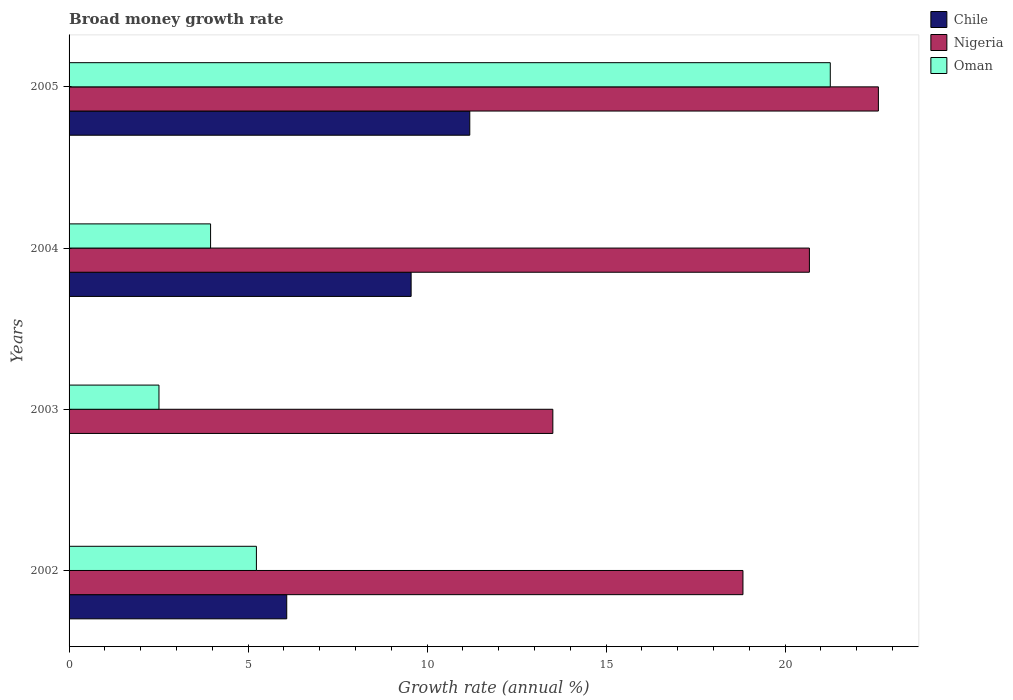How many bars are there on the 3rd tick from the top?
Make the answer very short. 2. How many bars are there on the 4th tick from the bottom?
Your response must be concise. 3. What is the label of the 2nd group of bars from the top?
Offer a very short reply. 2004. What is the growth rate in Nigeria in 2004?
Give a very brief answer. 20.68. Across all years, what is the maximum growth rate in Chile?
Keep it short and to the point. 11.19. Across all years, what is the minimum growth rate in Nigeria?
Give a very brief answer. 13.51. What is the total growth rate in Nigeria in the graph?
Ensure brevity in your answer.  75.61. What is the difference between the growth rate in Chile in 2002 and that in 2004?
Offer a terse response. -3.47. What is the difference between the growth rate in Chile in 2005 and the growth rate in Nigeria in 2003?
Offer a terse response. -2.32. What is the average growth rate in Nigeria per year?
Keep it short and to the point. 18.9. In the year 2005, what is the difference between the growth rate in Oman and growth rate in Nigeria?
Your answer should be compact. -1.34. What is the ratio of the growth rate in Nigeria in 2002 to that in 2004?
Provide a succinct answer. 0.91. Is the growth rate in Chile in 2004 less than that in 2005?
Provide a short and direct response. Yes. Is the difference between the growth rate in Oman in 2004 and 2005 greater than the difference between the growth rate in Nigeria in 2004 and 2005?
Your answer should be very brief. No. What is the difference between the highest and the second highest growth rate in Nigeria?
Your answer should be compact. 1.93. What is the difference between the highest and the lowest growth rate in Nigeria?
Keep it short and to the point. 9.09. How many bars are there?
Give a very brief answer. 11. Are all the bars in the graph horizontal?
Offer a terse response. Yes. Does the graph contain any zero values?
Ensure brevity in your answer.  Yes. Does the graph contain grids?
Provide a short and direct response. No. Where does the legend appear in the graph?
Keep it short and to the point. Top right. How many legend labels are there?
Your answer should be compact. 3. What is the title of the graph?
Ensure brevity in your answer.  Broad money growth rate. What is the label or title of the X-axis?
Give a very brief answer. Growth rate (annual %). What is the label or title of the Y-axis?
Keep it short and to the point. Years. What is the Growth rate (annual %) of Chile in 2002?
Ensure brevity in your answer.  6.08. What is the Growth rate (annual %) of Nigeria in 2002?
Your answer should be very brief. 18.82. What is the Growth rate (annual %) of Oman in 2002?
Make the answer very short. 5.23. What is the Growth rate (annual %) in Chile in 2003?
Your response must be concise. 0. What is the Growth rate (annual %) in Nigeria in 2003?
Provide a succinct answer. 13.51. What is the Growth rate (annual %) of Oman in 2003?
Provide a short and direct response. 2.51. What is the Growth rate (annual %) in Chile in 2004?
Your response must be concise. 9.55. What is the Growth rate (annual %) of Nigeria in 2004?
Your answer should be compact. 20.68. What is the Growth rate (annual %) in Oman in 2004?
Make the answer very short. 3.95. What is the Growth rate (annual %) of Chile in 2005?
Make the answer very short. 11.19. What is the Growth rate (annual %) in Nigeria in 2005?
Provide a succinct answer. 22.6. What is the Growth rate (annual %) of Oman in 2005?
Your answer should be compact. 21.26. Across all years, what is the maximum Growth rate (annual %) in Chile?
Offer a terse response. 11.19. Across all years, what is the maximum Growth rate (annual %) in Nigeria?
Provide a short and direct response. 22.6. Across all years, what is the maximum Growth rate (annual %) in Oman?
Give a very brief answer. 21.26. Across all years, what is the minimum Growth rate (annual %) of Chile?
Your response must be concise. 0. Across all years, what is the minimum Growth rate (annual %) in Nigeria?
Make the answer very short. 13.51. Across all years, what is the minimum Growth rate (annual %) of Oman?
Your answer should be very brief. 2.51. What is the total Growth rate (annual %) of Chile in the graph?
Your response must be concise. 26.82. What is the total Growth rate (annual %) of Nigeria in the graph?
Your answer should be very brief. 75.61. What is the total Growth rate (annual %) in Oman in the graph?
Ensure brevity in your answer.  32.96. What is the difference between the Growth rate (annual %) of Nigeria in 2002 and that in 2003?
Offer a terse response. 5.31. What is the difference between the Growth rate (annual %) in Oman in 2002 and that in 2003?
Offer a very short reply. 2.72. What is the difference between the Growth rate (annual %) of Chile in 2002 and that in 2004?
Provide a succinct answer. -3.47. What is the difference between the Growth rate (annual %) in Nigeria in 2002 and that in 2004?
Your answer should be very brief. -1.86. What is the difference between the Growth rate (annual %) in Oman in 2002 and that in 2004?
Keep it short and to the point. 1.28. What is the difference between the Growth rate (annual %) of Chile in 2002 and that in 2005?
Provide a succinct answer. -5.11. What is the difference between the Growth rate (annual %) in Nigeria in 2002 and that in 2005?
Give a very brief answer. -3.78. What is the difference between the Growth rate (annual %) in Oman in 2002 and that in 2005?
Provide a short and direct response. -16.03. What is the difference between the Growth rate (annual %) in Nigeria in 2003 and that in 2004?
Give a very brief answer. -7.17. What is the difference between the Growth rate (annual %) of Oman in 2003 and that in 2004?
Your response must be concise. -1.44. What is the difference between the Growth rate (annual %) of Nigeria in 2003 and that in 2005?
Your answer should be compact. -9.09. What is the difference between the Growth rate (annual %) in Oman in 2003 and that in 2005?
Provide a succinct answer. -18.75. What is the difference between the Growth rate (annual %) in Chile in 2004 and that in 2005?
Offer a terse response. -1.64. What is the difference between the Growth rate (annual %) in Nigeria in 2004 and that in 2005?
Provide a succinct answer. -1.93. What is the difference between the Growth rate (annual %) in Oman in 2004 and that in 2005?
Ensure brevity in your answer.  -17.31. What is the difference between the Growth rate (annual %) in Chile in 2002 and the Growth rate (annual %) in Nigeria in 2003?
Make the answer very short. -7.43. What is the difference between the Growth rate (annual %) of Chile in 2002 and the Growth rate (annual %) of Oman in 2003?
Offer a terse response. 3.57. What is the difference between the Growth rate (annual %) in Nigeria in 2002 and the Growth rate (annual %) in Oman in 2003?
Keep it short and to the point. 16.31. What is the difference between the Growth rate (annual %) of Chile in 2002 and the Growth rate (annual %) of Nigeria in 2004?
Make the answer very short. -14.6. What is the difference between the Growth rate (annual %) in Chile in 2002 and the Growth rate (annual %) in Oman in 2004?
Offer a terse response. 2.13. What is the difference between the Growth rate (annual %) in Nigeria in 2002 and the Growth rate (annual %) in Oman in 2004?
Provide a short and direct response. 14.87. What is the difference between the Growth rate (annual %) in Chile in 2002 and the Growth rate (annual %) in Nigeria in 2005?
Give a very brief answer. -16.52. What is the difference between the Growth rate (annual %) of Chile in 2002 and the Growth rate (annual %) of Oman in 2005?
Your answer should be very brief. -15.18. What is the difference between the Growth rate (annual %) of Nigeria in 2002 and the Growth rate (annual %) of Oman in 2005?
Offer a very short reply. -2.44. What is the difference between the Growth rate (annual %) in Nigeria in 2003 and the Growth rate (annual %) in Oman in 2004?
Provide a short and direct response. 9.56. What is the difference between the Growth rate (annual %) of Nigeria in 2003 and the Growth rate (annual %) of Oman in 2005?
Ensure brevity in your answer.  -7.75. What is the difference between the Growth rate (annual %) in Chile in 2004 and the Growth rate (annual %) in Nigeria in 2005?
Your response must be concise. -13.05. What is the difference between the Growth rate (annual %) in Chile in 2004 and the Growth rate (annual %) in Oman in 2005?
Your response must be concise. -11.71. What is the difference between the Growth rate (annual %) of Nigeria in 2004 and the Growth rate (annual %) of Oman in 2005?
Make the answer very short. -0.58. What is the average Growth rate (annual %) of Chile per year?
Make the answer very short. 6.71. What is the average Growth rate (annual %) in Nigeria per year?
Make the answer very short. 18.9. What is the average Growth rate (annual %) in Oman per year?
Offer a very short reply. 8.24. In the year 2002, what is the difference between the Growth rate (annual %) in Chile and Growth rate (annual %) in Nigeria?
Ensure brevity in your answer.  -12.74. In the year 2002, what is the difference between the Growth rate (annual %) of Chile and Growth rate (annual %) of Oman?
Provide a succinct answer. 0.85. In the year 2002, what is the difference between the Growth rate (annual %) of Nigeria and Growth rate (annual %) of Oman?
Your answer should be compact. 13.59. In the year 2003, what is the difference between the Growth rate (annual %) of Nigeria and Growth rate (annual %) of Oman?
Give a very brief answer. 11. In the year 2004, what is the difference between the Growth rate (annual %) of Chile and Growth rate (annual %) of Nigeria?
Provide a succinct answer. -11.12. In the year 2004, what is the difference between the Growth rate (annual %) of Chile and Growth rate (annual %) of Oman?
Ensure brevity in your answer.  5.6. In the year 2004, what is the difference between the Growth rate (annual %) in Nigeria and Growth rate (annual %) in Oman?
Provide a short and direct response. 16.72. In the year 2005, what is the difference between the Growth rate (annual %) of Chile and Growth rate (annual %) of Nigeria?
Keep it short and to the point. -11.41. In the year 2005, what is the difference between the Growth rate (annual %) of Chile and Growth rate (annual %) of Oman?
Your answer should be very brief. -10.07. In the year 2005, what is the difference between the Growth rate (annual %) in Nigeria and Growth rate (annual %) in Oman?
Make the answer very short. 1.34. What is the ratio of the Growth rate (annual %) of Nigeria in 2002 to that in 2003?
Your answer should be compact. 1.39. What is the ratio of the Growth rate (annual %) in Oman in 2002 to that in 2003?
Make the answer very short. 2.08. What is the ratio of the Growth rate (annual %) of Chile in 2002 to that in 2004?
Your response must be concise. 0.64. What is the ratio of the Growth rate (annual %) of Nigeria in 2002 to that in 2004?
Keep it short and to the point. 0.91. What is the ratio of the Growth rate (annual %) in Oman in 2002 to that in 2004?
Your response must be concise. 1.32. What is the ratio of the Growth rate (annual %) of Chile in 2002 to that in 2005?
Make the answer very short. 0.54. What is the ratio of the Growth rate (annual %) in Nigeria in 2002 to that in 2005?
Provide a succinct answer. 0.83. What is the ratio of the Growth rate (annual %) in Oman in 2002 to that in 2005?
Offer a very short reply. 0.25. What is the ratio of the Growth rate (annual %) in Nigeria in 2003 to that in 2004?
Your answer should be very brief. 0.65. What is the ratio of the Growth rate (annual %) in Oman in 2003 to that in 2004?
Give a very brief answer. 0.64. What is the ratio of the Growth rate (annual %) in Nigeria in 2003 to that in 2005?
Offer a very short reply. 0.6. What is the ratio of the Growth rate (annual %) of Oman in 2003 to that in 2005?
Offer a terse response. 0.12. What is the ratio of the Growth rate (annual %) of Chile in 2004 to that in 2005?
Provide a succinct answer. 0.85. What is the ratio of the Growth rate (annual %) in Nigeria in 2004 to that in 2005?
Keep it short and to the point. 0.91. What is the ratio of the Growth rate (annual %) of Oman in 2004 to that in 2005?
Make the answer very short. 0.19. What is the difference between the highest and the second highest Growth rate (annual %) of Chile?
Your answer should be compact. 1.64. What is the difference between the highest and the second highest Growth rate (annual %) in Nigeria?
Provide a short and direct response. 1.93. What is the difference between the highest and the second highest Growth rate (annual %) of Oman?
Keep it short and to the point. 16.03. What is the difference between the highest and the lowest Growth rate (annual %) in Chile?
Make the answer very short. 11.19. What is the difference between the highest and the lowest Growth rate (annual %) of Nigeria?
Provide a succinct answer. 9.09. What is the difference between the highest and the lowest Growth rate (annual %) in Oman?
Keep it short and to the point. 18.75. 